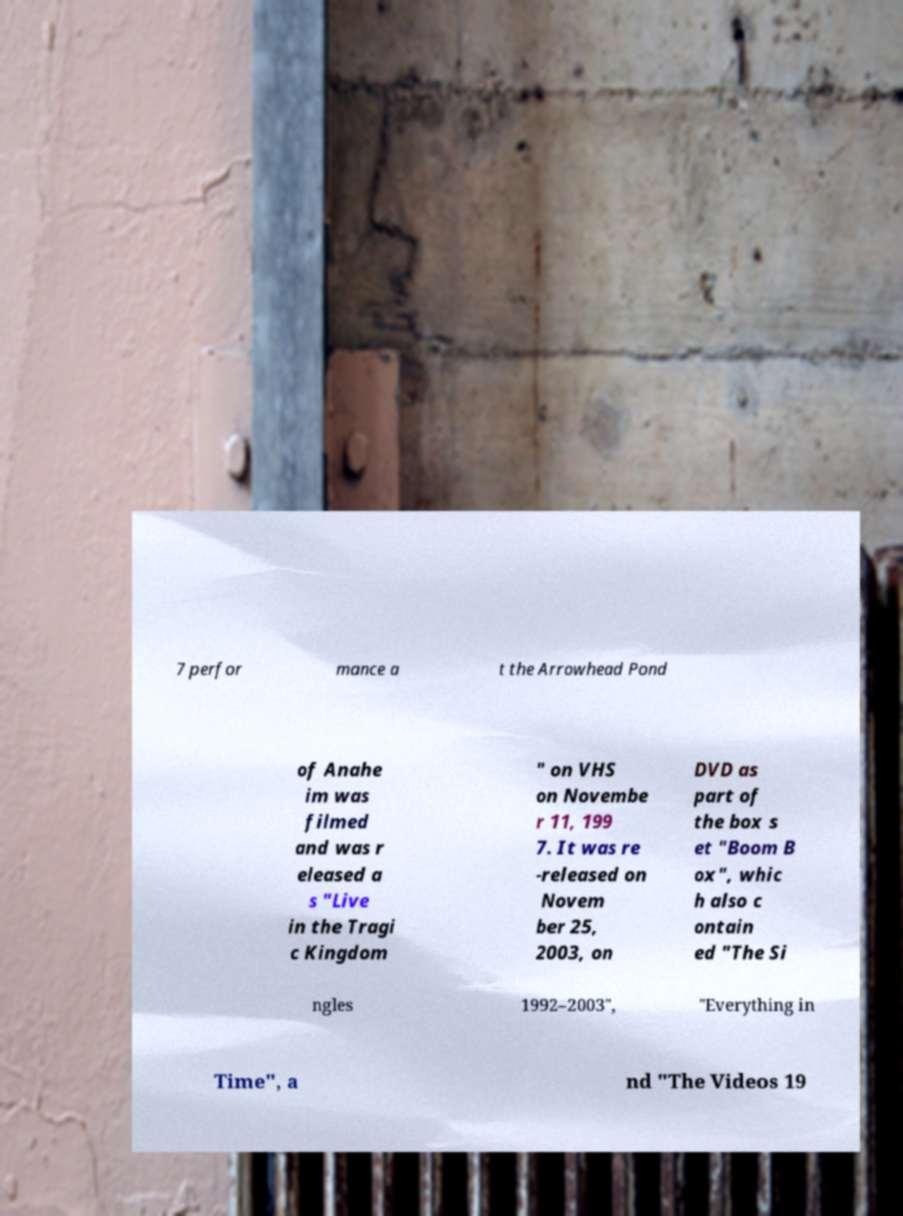Can you read and provide the text displayed in the image?This photo seems to have some interesting text. Can you extract and type it out for me? 7 perfor mance a t the Arrowhead Pond of Anahe im was filmed and was r eleased a s "Live in the Tragi c Kingdom " on VHS on Novembe r 11, 199 7. It was re -released on Novem ber 25, 2003, on DVD as part of the box s et "Boom B ox", whic h also c ontain ed "The Si ngles 1992–2003", "Everything in Time", a nd "The Videos 19 